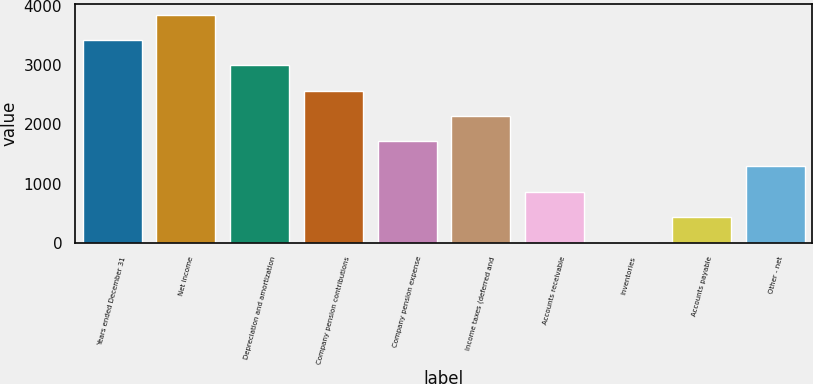Convert chart to OTSL. <chart><loc_0><loc_0><loc_500><loc_500><bar_chart><fcel>Years ended December 31<fcel>Net income<fcel>Depreciation and amortization<fcel>Company pension contributions<fcel>Company pension expense<fcel>Income taxes (deferred and<fcel>Accounts receivable<fcel>Inventories<fcel>Accounts payable<fcel>Other - net<nl><fcel>3427<fcel>3854.5<fcel>2999.5<fcel>2572<fcel>1717<fcel>2144.5<fcel>862<fcel>7<fcel>434.5<fcel>1289.5<nl></chart> 